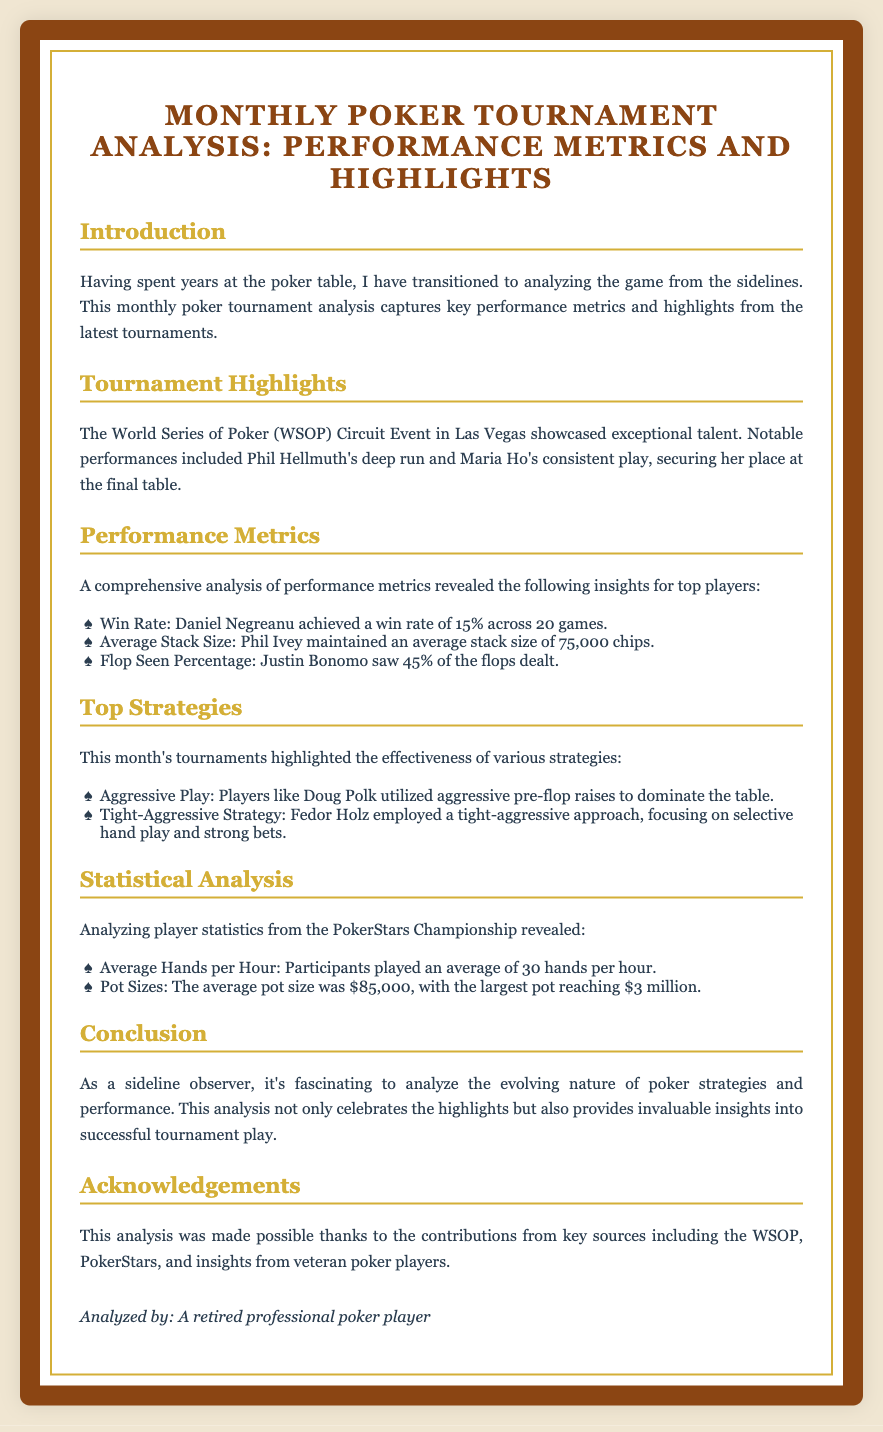What was the title of the diploma? The title is found in the header of the document, which is "Monthly Poker Tournament Analysis: Performance Metrics and Highlights."
Answer: Monthly Poker Tournament Analysis: Performance Metrics and Highlights Who had a deep run at the WSOP Circuit Event? This information is mentioned in the tournament highlights section, specifically stating Phil Hellmuth had a deep run.
Answer: Phil Hellmuth What was Daniel Negreanu's win rate? The win rate for Daniel Negreanu is provided in the performance metrics section as 15%.
Answer: 15% What is the average pot size mentioned in the statistical analysis? The average pot size can be found in the statistical analysis section, where it is listed as $85,000.
Answer: $85,000 What strategy did Fedor Holz employ? The strategy used by Fedor Holz is described in the top strategies section as a tight-aggressive approach.
Answer: Tight-Aggressive Strategy How many hands per hour did players average? This statistic is provided in the statistical analysis section, which mentions an average of 30 hands per hour.
Answer: 30 What were the notable performances in the tournament highlights? Notable performances are discussed in the tournament highlights, mentioning Phil Hellmuth and Maria Ho.
Answer: Phil Hellmuth and Maria Ho What type of play did Doug Polk utilize? The type of play used by Doug Polk is described in the top strategies section as aggressive play.
Answer: Aggressive Play 